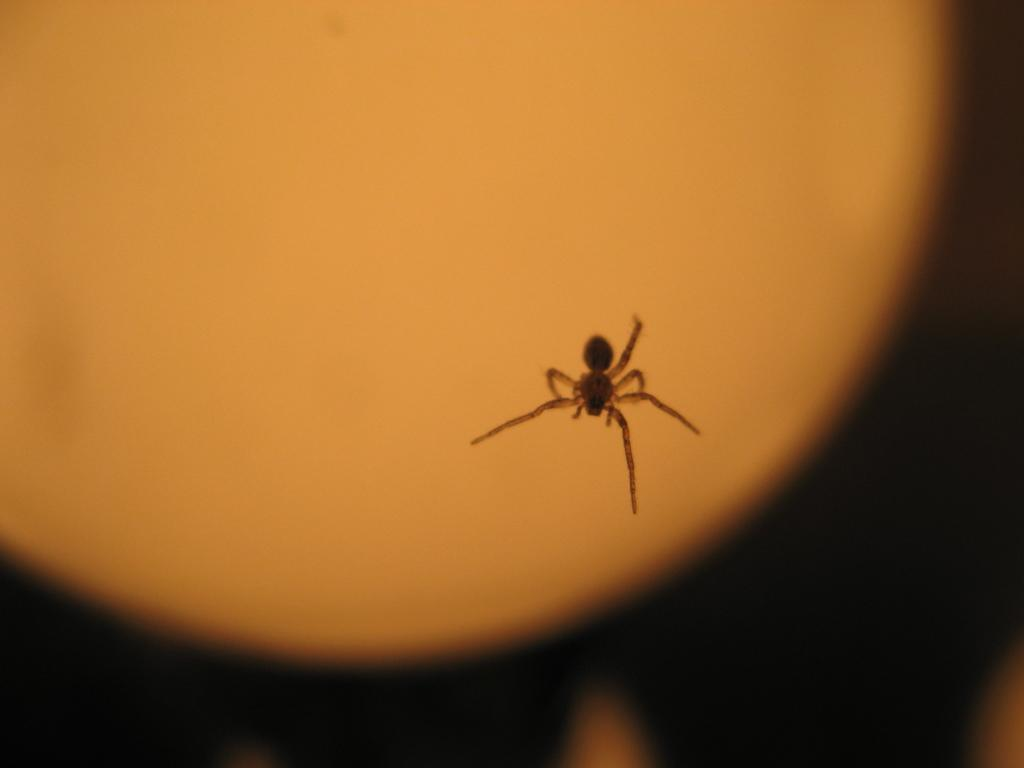What is the main subject of the picture? There is a spider in the picture. What color is the background of the image? The background of the image is orange. How would you describe the bottom part of the image? The bottom of the image is dark. What type of wool can be seen hanging from the tree in the image? There is no wool or tree present in the image; it features a spider with an orange background and a dark bottom. 